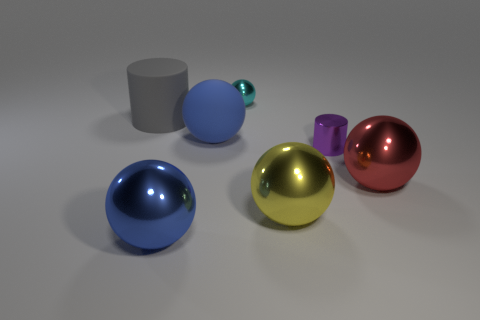Subtract all cyan spheres. How many spheres are left? 4 Subtract all small cyan balls. How many balls are left? 4 Subtract all brown balls. Subtract all red cubes. How many balls are left? 5 Add 2 purple shiny things. How many objects exist? 9 Subtract all spheres. How many objects are left? 2 Add 5 large yellow things. How many large yellow things are left? 6 Add 5 large red objects. How many large red objects exist? 6 Subtract 0 green spheres. How many objects are left? 7 Subtract all tiny cyan balls. Subtract all spheres. How many objects are left? 1 